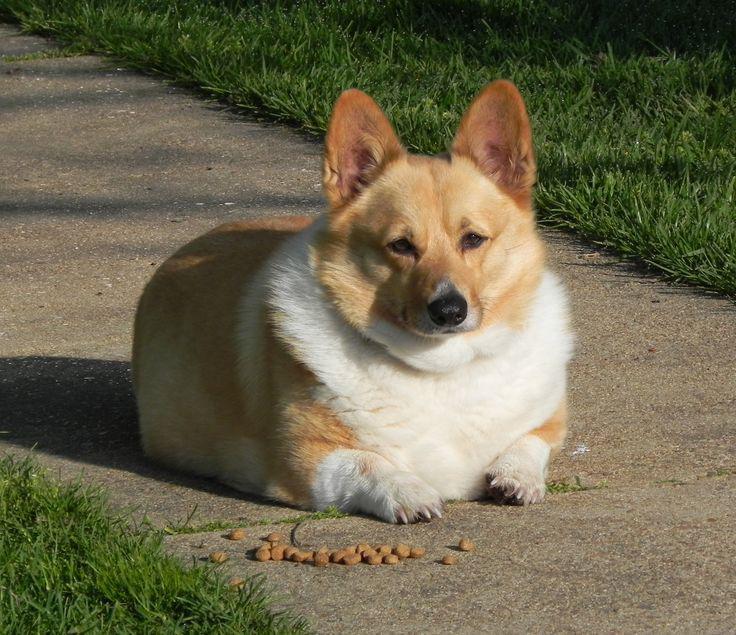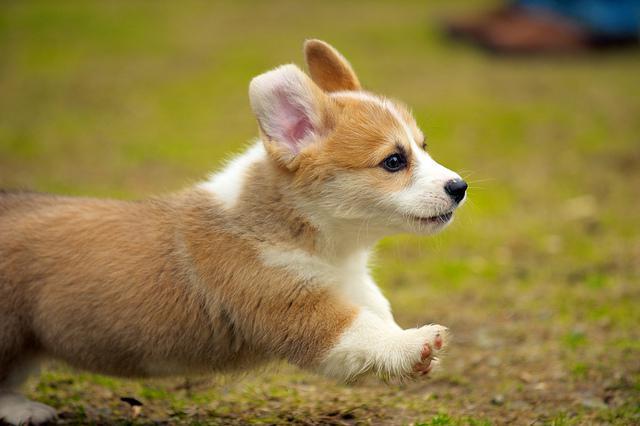The first image is the image on the left, the second image is the image on the right. Analyze the images presented: Is the assertion "A dog in one image has a partial black coat and is looking up with its mouth open." valid? Answer yes or no. No. 